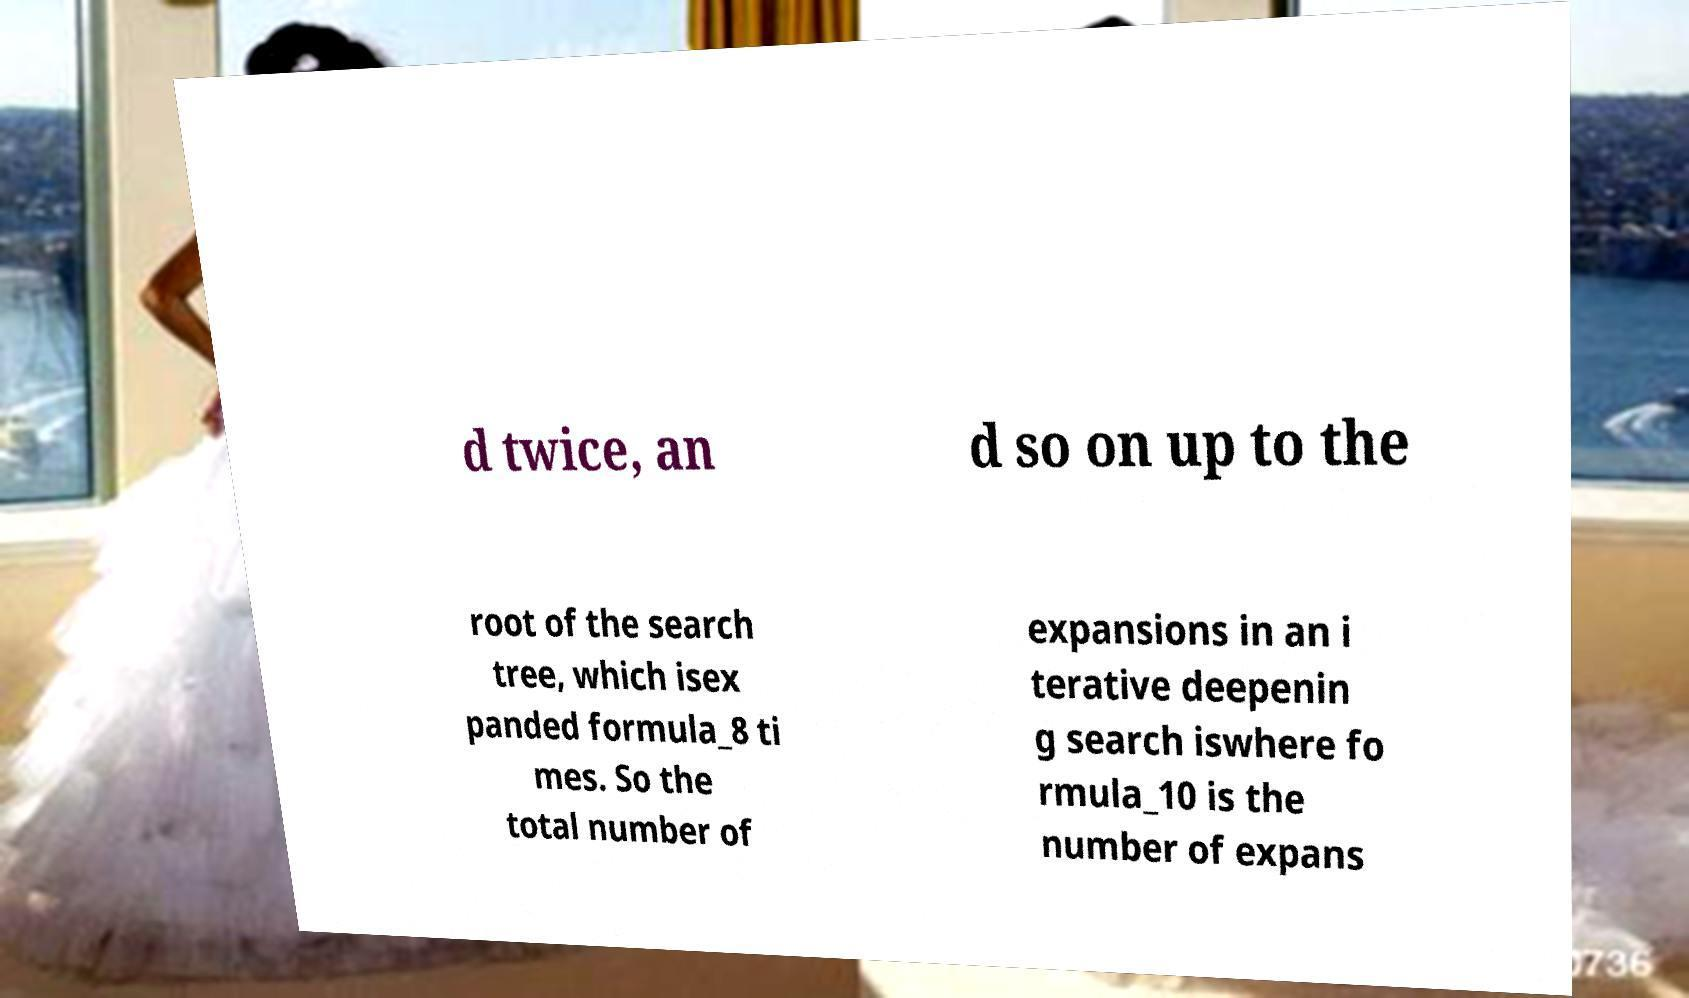I need the written content from this picture converted into text. Can you do that? d twice, an d so on up to the root of the search tree, which isex panded formula_8 ti mes. So the total number of expansions in an i terative deepenin g search iswhere fo rmula_10 is the number of expans 